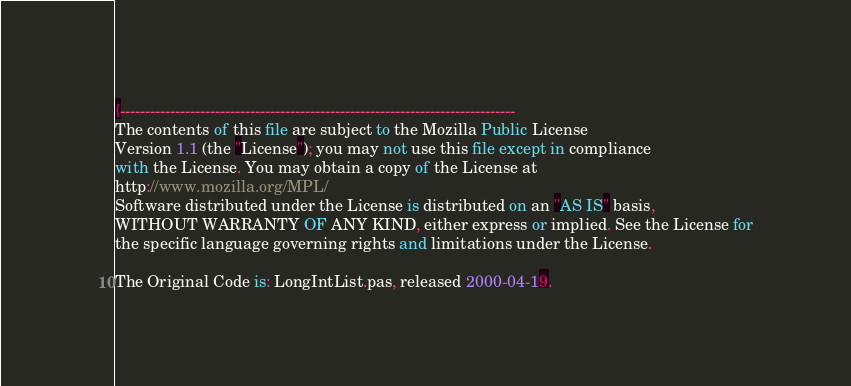Convert code to text. <code><loc_0><loc_0><loc_500><loc_500><_Pascal_>{-------------------------------------------------------------------------------
The contents of this file are subject to the Mozilla Public License
Version 1.1 (the "License"); you may not use this file except in compliance
with the License. You may obtain a copy of the License at
http://www.mozilla.org/MPL/
Software distributed under the License is distributed on an "AS IS" basis,
WITHOUT WARRANTY OF ANY KIND, either express or implied. See the License for
the specific language governing rights and limitations under the License.

The Original Code is: LongIntList.pas, released 2000-04-19.
</code> 